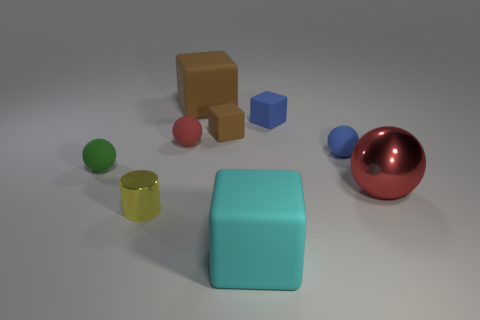Does the tiny brown block have the same material as the large brown block?
Ensure brevity in your answer.  Yes. There is a blue thing that is the same shape as the big cyan object; what size is it?
Your response must be concise. Small. How many objects are small green rubber objects that are in front of the tiny blue matte ball or cubes behind the big metal thing?
Your answer should be compact. 4. Are there fewer small matte balls than blue objects?
Make the answer very short. No. There is a yellow metal thing; does it have the same size as the red sphere that is to the right of the cyan thing?
Your answer should be very brief. No. What number of matte things are big spheres or tiny gray cylinders?
Offer a very short reply. 0. Is the number of small blue matte cubes greater than the number of cubes?
Keep it short and to the point. No. What size is the rubber sphere that is the same color as the shiny sphere?
Make the answer very short. Small. What is the shape of the rubber object in front of the sphere left of the red rubber object?
Offer a terse response. Cube. Are there any tiny green rubber spheres in front of the big block that is in front of the big red thing on the right side of the cyan matte block?
Your answer should be compact. No. 